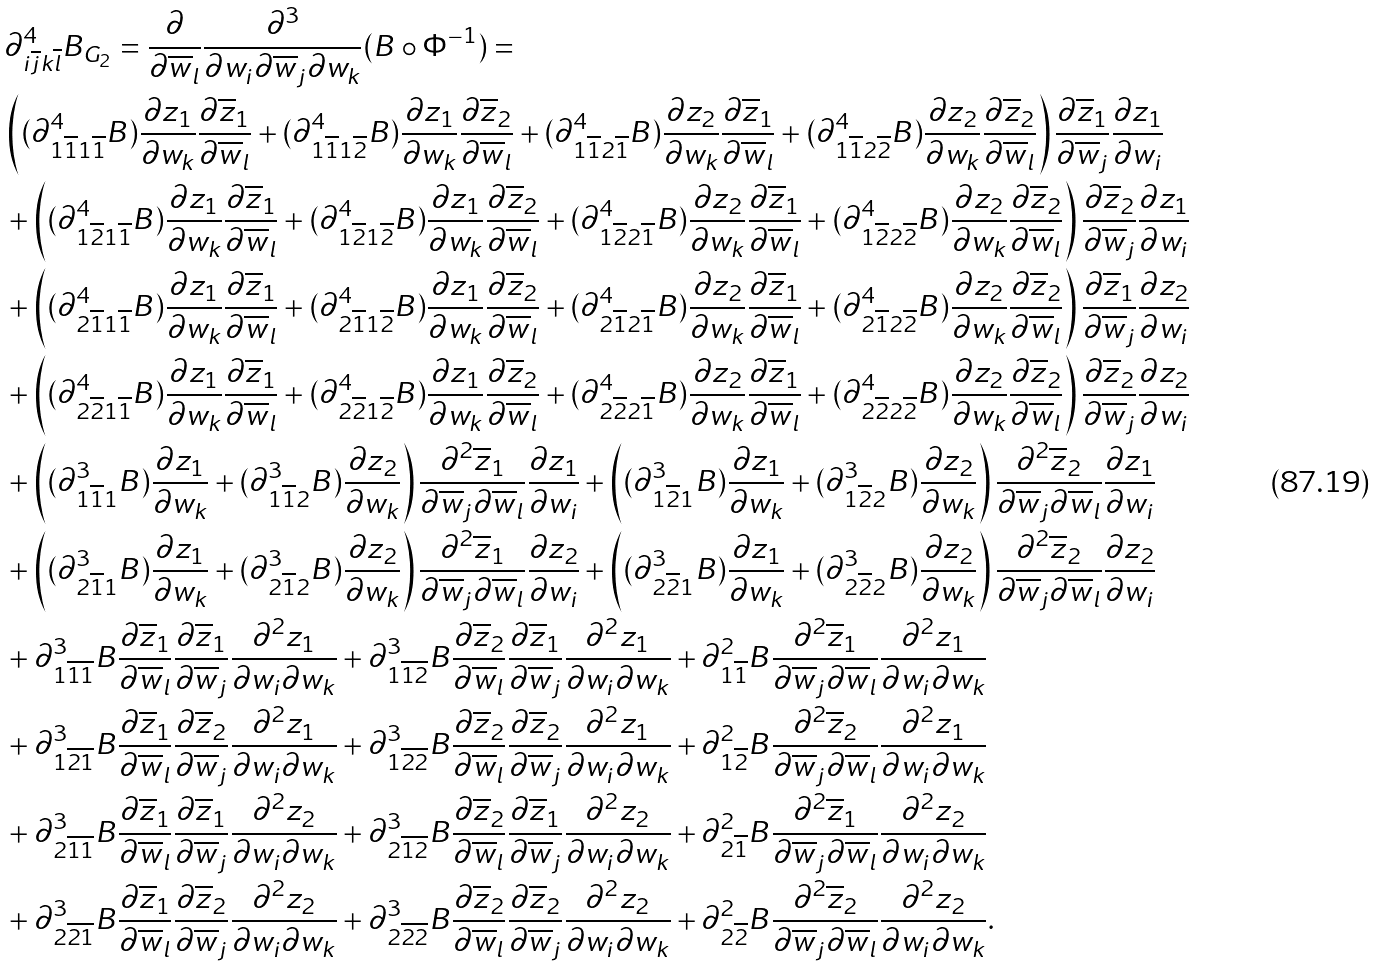Convert formula to latex. <formula><loc_0><loc_0><loc_500><loc_500>& \partial ^ { 4 } _ { i \overline { j } k \overline { l } } { B _ { G _ { 2 } } } = \frac { \partial } { \partial \overline { w } _ { l } } \frac { \partial ^ { 3 } } { \partial w _ { i } \partial \overline { w } _ { j } \partial w _ { k } } ( B \circ \Phi ^ { - 1 } ) = \\ & \left ( ( \partial ^ { 4 } _ { 1 \overline { 1 } 1 \overline { 1 } } B ) \frac { \partial z _ { 1 } } { \partial w _ { k } } \frac { \partial \overline { z } _ { 1 } } { \partial \overline { w } _ { l } } + ( \partial ^ { 4 } _ { 1 \overline { 1 } 1 \overline { 2 } } B ) \frac { \partial z _ { 1 } } { \partial w _ { k } } \frac { \partial \overline { z } _ { 2 } } { \partial \overline { w } _ { l } } + ( \partial ^ { 4 } _ { 1 \overline { 1 } 2 \overline { 1 } } B ) \frac { \partial z _ { 2 } } { \partial w _ { k } } \frac { \partial \overline { z } _ { 1 } } { \partial \overline { w } _ { l } } + ( \partial ^ { 4 } _ { 1 \overline { 1 } 2 \overline { 2 } } B ) \frac { \partial z _ { 2 } } { \partial w _ { k } } \frac { \partial \overline { z } _ { 2 } } { \partial \overline { w } _ { l } } \right ) \frac { \partial \overline { z } _ { 1 } } { \partial \overline { w } _ { j } } \frac { \partial { z } _ { 1 } } { \partial { w } _ { i } } \\ & + \left ( ( \partial ^ { 4 } _ { 1 \overline { 2 } 1 \overline { 1 } } B ) \frac { \partial z _ { 1 } } { \partial w _ { k } } \frac { \partial \overline { z } _ { 1 } } { \partial \overline { w } _ { l } } + ( \partial ^ { 4 } _ { 1 \overline { 2 } 1 \overline { 2 } } B ) \frac { \partial z _ { 1 } } { \partial w _ { k } } \frac { \partial \overline { z } _ { 2 } } { \partial \overline { w } _ { l } } + ( \partial ^ { 4 } _ { 1 \overline { 2 } 2 \overline { 1 } } B ) \frac { \partial z _ { 2 } } { \partial w _ { k } } \frac { \partial \overline { z } _ { 1 } } { \partial \overline { w } _ { l } } + ( \partial ^ { 4 } _ { 1 \overline { 2 } 2 \overline { 2 } } B ) \frac { \partial z _ { 2 } } { \partial w _ { k } } \frac { \partial \overline { z } _ { 2 } } { \partial \overline { w } _ { l } } \right ) \frac { \partial \overline { z } _ { 2 } } { \partial \overline { w } _ { j } } \frac { \partial { z } _ { 1 } } { \partial { w } _ { i } } \\ & + \left ( ( \partial ^ { 4 } _ { 2 \overline { 1 } 1 \overline { 1 } } B ) \frac { \partial z _ { 1 } } { \partial w _ { k } } \frac { \partial \overline { z } _ { 1 } } { \partial \overline { w } _ { l } } + ( \partial ^ { 4 } _ { 2 \overline { 1 } 1 \overline { 2 } } B ) \frac { \partial z _ { 1 } } { \partial w _ { k } } \frac { \partial \overline { z } _ { 2 } } { \partial \overline { w } _ { l } } + ( \partial ^ { 4 } _ { 2 \overline { 1 } 2 \overline { 1 } } B ) \frac { \partial z _ { 2 } } { \partial w _ { k } } \frac { \partial \overline { z } _ { 1 } } { \partial \overline { w } _ { l } } + ( \partial ^ { 4 } _ { 2 \overline { 1 } 2 \overline { 2 } } B ) \frac { \partial z _ { 2 } } { \partial w _ { k } } \frac { \partial \overline { z } _ { 2 } } { \partial \overline { w } _ { l } } \right ) \frac { \partial \overline { z } _ { 1 } } { \partial \overline { w } _ { j } } \frac { \partial { z } _ { 2 } } { \partial { w } _ { i } } \\ & + \left ( ( \partial ^ { 4 } _ { 2 \overline { 2 } 1 \overline { 1 } } B ) \frac { \partial z _ { 1 } } { \partial w _ { k } } \frac { \partial \overline { z } _ { 1 } } { \partial \overline { w } _ { l } } + ( \partial ^ { 4 } _ { 2 \overline { 2 } 1 \overline { 2 } } B ) \frac { \partial z _ { 1 } } { \partial w _ { k } } \frac { \partial \overline { z } _ { 2 } } { \partial \overline { w } _ { l } } + ( \partial ^ { 4 } _ { 2 \overline { 2 } 2 \overline { 1 } } B ) \frac { \partial z _ { 2 } } { \partial w _ { k } } \frac { \partial \overline { z } _ { 1 } } { \partial \overline { w } _ { l } } + ( \partial ^ { 4 } _ { 2 \overline { 2 } 2 \overline { 2 } } B ) \frac { \partial z _ { 2 } } { \partial w _ { k } } \frac { \partial \overline { z } _ { 2 } } { \partial \overline { w } _ { l } } \right ) \frac { \partial \overline { z } _ { 2 } } { \partial \overline { w } _ { j } } \frac { \partial { z } _ { 2 } } { \partial { w } _ { i } } \\ & + \left ( ( \partial ^ { 3 } _ { 1 \overline { 1 } 1 } B ) \frac { \partial z _ { 1 } } { \partial w _ { k } } + ( \partial ^ { 3 } _ { 1 \overline { 1 } 2 } B ) \frac { \partial z _ { 2 } } { \partial w _ { k } } \right ) \frac { \partial ^ { 2 } \overline { z } _ { 1 } } { \partial \overline { w } _ { j } \partial \overline { w } _ { l } } \frac { \partial { z } _ { 1 } } { \partial { w } _ { i } } + \left ( ( \partial ^ { 3 } _ { 1 \overline { 2 } 1 } B ) \frac { \partial z _ { 1 } } { \partial w _ { k } } + ( \partial ^ { 3 } _ { 1 \overline { 2 } 2 } B ) \frac { \partial z _ { 2 } } { \partial w _ { k } } \right ) \frac { \partial ^ { 2 } \overline { z } _ { 2 } } { \partial \overline { w } _ { j } \partial \overline { w } _ { l } } \frac { \partial { z } _ { 1 } } { \partial { w } _ { i } } \\ & + \left ( ( \partial ^ { 3 } _ { 2 \overline { 1 } 1 } B ) \frac { \partial z _ { 1 } } { \partial w _ { k } } + ( \partial ^ { 3 } _ { 2 \overline { 1 } 2 } B ) \frac { \partial z _ { 2 } } { \partial w _ { k } } \right ) \frac { \partial ^ { 2 } \overline { z } _ { 1 } } { \partial \overline { w } _ { j } \partial \overline { w } _ { l } } \frac { \partial { z } _ { 2 } } { \partial { w } _ { i } } + \left ( ( \partial ^ { 3 } _ { 2 \overline { 2 } 1 } B ) \frac { \partial z _ { 1 } } { \partial w _ { k } } + ( \partial ^ { 3 } _ { 2 \overline { 2 } 2 } B ) \frac { \partial z _ { 2 } } { \partial w _ { k } } \right ) \frac { \partial ^ { 2 } \overline { z } _ { 2 } } { \partial \overline { w } _ { j } \partial \overline { w } _ { l } } \frac { \partial { z } _ { 2 } } { \partial { w } _ { i } } \\ & + \partial ^ { 3 } _ { 1 \overline { 1 } \overline { 1 } } B \frac { \partial \overline { z } _ { 1 } } { \partial \overline { w } _ { l } } \frac { \partial \overline { z } _ { 1 } } { \partial \overline { w } _ { j } } \frac { \partial ^ { 2 } z _ { 1 } } { \partial w _ { i } \partial w _ { k } } + \partial ^ { 3 } _ { 1 \overline { 1 } \overline { 2 } } B \frac { \partial \overline { z } _ { 2 } } { \partial \overline { w } _ { l } } \frac { \partial \overline { z } _ { 1 } } { \partial \overline { w } _ { j } } \frac { \partial ^ { 2 } z _ { 1 } } { \partial w _ { i } \partial w _ { k } } + \partial ^ { 2 } _ { 1 \overline { 1 } } B \frac { \partial ^ { 2 } \overline { z } _ { 1 } } { \partial \overline { w } _ { j } \partial \overline { w } _ { l } } \frac { \partial ^ { 2 } z _ { 1 } } { \partial w _ { i } \partial w _ { k } } \\ & + \partial ^ { 3 } _ { 1 \overline { 2 } \overline { 1 } } B \frac { \partial \overline { z } _ { 1 } } { \partial \overline { w } _ { l } } \frac { \partial \overline { z } _ { 2 } } { \partial \overline { w } _ { j } } \frac { \partial ^ { 2 } z _ { 1 } } { \partial w _ { i } \partial w _ { k } } + \partial ^ { 3 } _ { 1 \overline { 2 } \overline { 2 } } B \frac { \partial \overline { z } _ { 2 } } { \partial \overline { w } _ { l } } \frac { \partial \overline { z } _ { 2 } } { \partial \overline { w } _ { j } } \frac { \partial ^ { 2 } z _ { 1 } } { \partial w _ { i } \partial w _ { k } } + \partial ^ { 2 } _ { 1 \overline { 2 } } B \frac { \partial ^ { 2 } \overline { z } _ { 2 } } { \partial \overline { w } _ { j } \partial \overline { w } _ { l } } \frac { \partial ^ { 2 } z _ { 1 } } { \partial w _ { i } \partial w _ { k } } \\ & + \partial ^ { 3 } _ { 2 \overline { 1 } \overline { 1 } } B \frac { \partial \overline { z } _ { 1 } } { \partial \overline { w } _ { l } } \frac { \partial \overline { z } _ { 1 } } { \partial \overline { w } _ { j } } \frac { \partial ^ { 2 } z _ { 2 } } { \partial w _ { i } \partial w _ { k } } + \partial ^ { 3 } _ { 2 \overline { 1 } \overline { 2 } } B \frac { \partial \overline { z } _ { 2 } } { \partial \overline { w } _ { l } } \frac { \partial \overline { z } _ { 1 } } { \partial \overline { w } _ { j } } \frac { \partial ^ { 2 } z _ { 2 } } { \partial w _ { i } \partial w _ { k } } + \partial ^ { 2 } _ { { 2 } \overline { 1 } } B \frac { \partial ^ { 2 } \overline { z } _ { 1 } } { \partial \overline { w } _ { j } \partial \overline { w } _ { l } } \frac { \partial ^ { 2 } z _ { 2 } } { \partial w _ { i } \partial w _ { k } } \\ & + \partial ^ { 3 } _ { 2 \overline { 2 } \overline { 1 } } B \frac { \partial \overline { z } _ { 1 } } { \partial \overline { w } _ { l } } \frac { \partial \overline { z } _ { 2 } } { \partial \overline { w } _ { j } } \frac { \partial ^ { 2 } z _ { 2 } } { \partial w _ { i } \partial w _ { k } } + \partial ^ { 3 } _ { 2 \overline { 2 } \overline { 2 } } B \frac { \partial \overline { z } _ { 2 } } { \partial \overline { w } _ { l } } \frac { \partial \overline { z } _ { 2 } } { \partial \overline { w } _ { j } } \frac { \partial ^ { 2 } z _ { 2 } } { \partial w _ { i } \partial w _ { k } } + \partial ^ { 2 } _ { 2 \overline { 2 } } B \frac { \partial ^ { 2 } \overline { z } _ { 2 } } { \partial \overline { w } _ { j } \partial \overline { w } _ { l } } \frac { \partial ^ { 2 } z _ { 2 } } { \partial w _ { i } \partial w _ { k } } .</formula> 